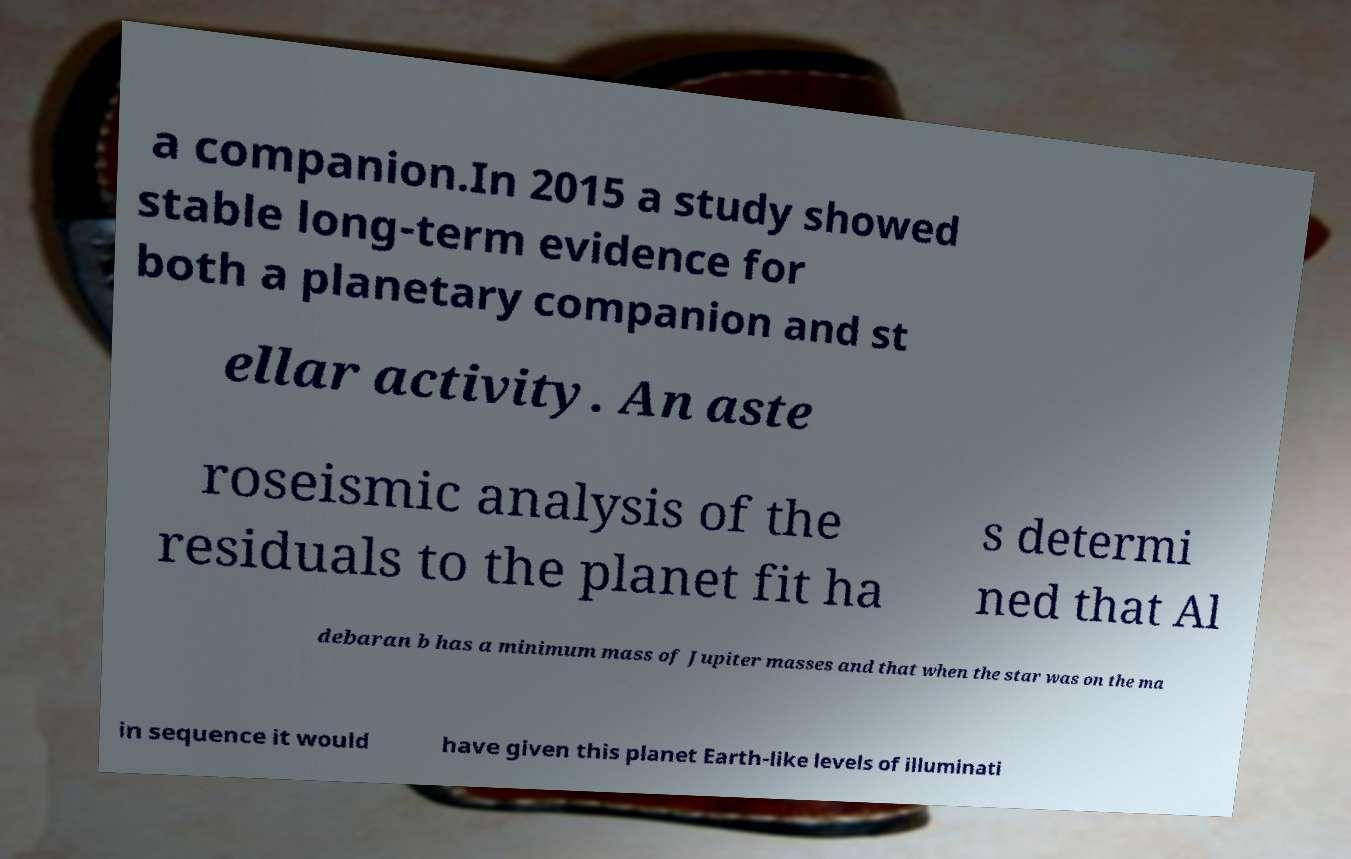Please read and relay the text visible in this image. What does it say? a companion.In 2015 a study showed stable long-term evidence for both a planetary companion and st ellar activity. An aste roseismic analysis of the residuals to the planet fit ha s determi ned that Al debaran b has a minimum mass of Jupiter masses and that when the star was on the ma in sequence it would have given this planet Earth-like levels of illuminati 